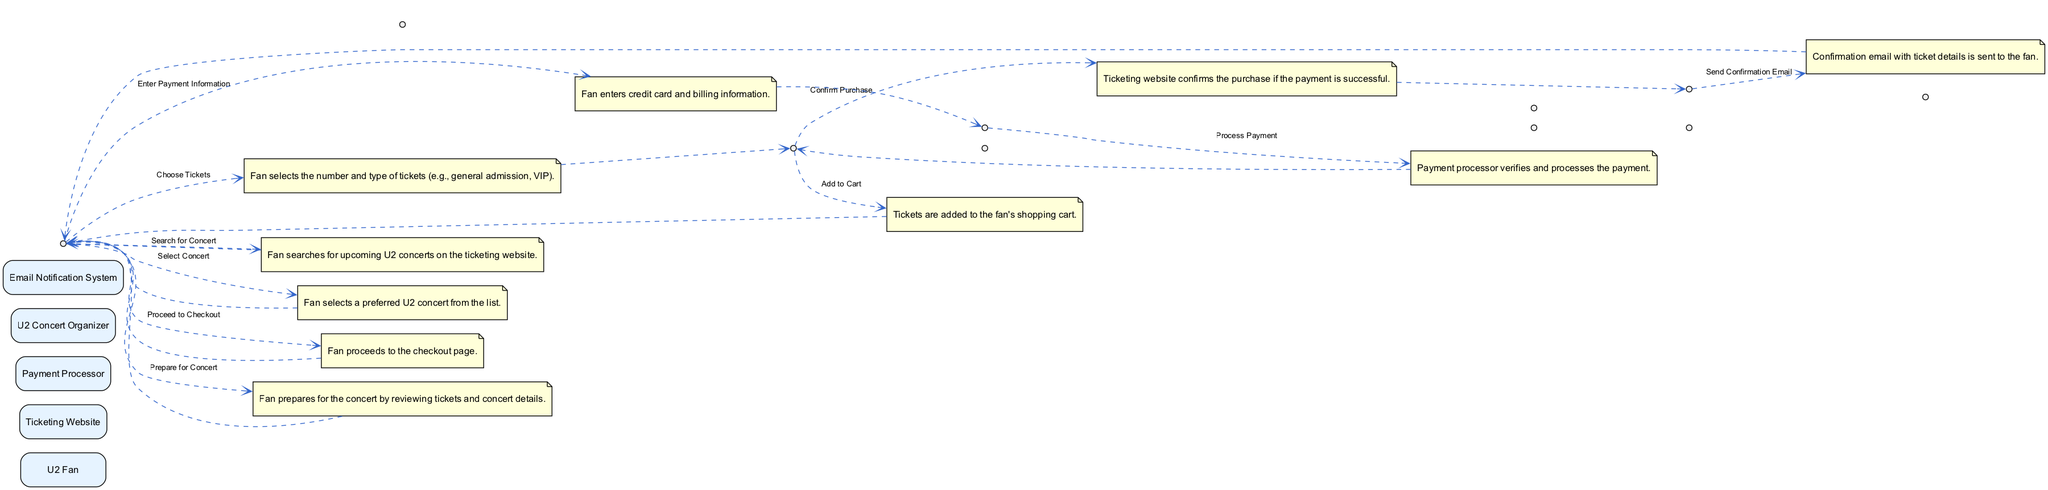What is the first step in the ticket purchasing process? The first step listed in the diagram is "Search for Concert," indicating that it is the initial action taken by the U2 Fan.
Answer: Search for Concert How many actors are involved in the ticket purchasing process? The diagram includes five actors: U2 Fan, Ticketing Website, Payment Processor, U2 Concert Organizer, and Email Notification System.
Answer: Five Which actor sends the confirmation email? Referring to the diagram, the Email Notification System is responsible for sending the confirmation email to the fan.
Answer: Email Notification System What follows after the "Process Payment" step? The sequence of steps shows that the "Confirm Purchase" follows immediately after the "Process Payment" step.
Answer: Confirm Purchase Which step does the "Ticketing Website" complete? Upon reviewing the diagram, the Ticketing Website completes the steps of "Add to Cart" and "Confirm Purchase."
Answer: Add to Cart, Confirm Purchase Who is responsible for processing the payment? The diagram clearly states that the Payment Processor is the actor responsible for processing the payment during the ticket purchasing process.
Answer: Payment Processor Which actor does the U2 Fan interact with to choose tickets? According to the diagram, the U2 Fan directly engages with the Ticketing Website to choose tickets after selecting their concert.
Answer: Ticketing Website What is the last action the U2 Fan performs in the process? The final action listed for the U2 Fan is "Prepare for Concert," indicating that this is the last step they take after completing the purchase.
Answer: Prepare for Concert Which step connects the Payment Processor to the Ticketing Website? The step connecting them is "Process Payment," as it links the Payment Processor's action to the Ticketing Website's confirmation of purchase.
Answer: Process Payment 